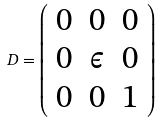Convert formula to latex. <formula><loc_0><loc_0><loc_500><loc_500>D = \left ( \begin{array} { c c c } 0 & 0 & 0 \\ 0 & \epsilon & 0 \\ 0 & 0 & 1 \\ \end{array} \right )</formula> 